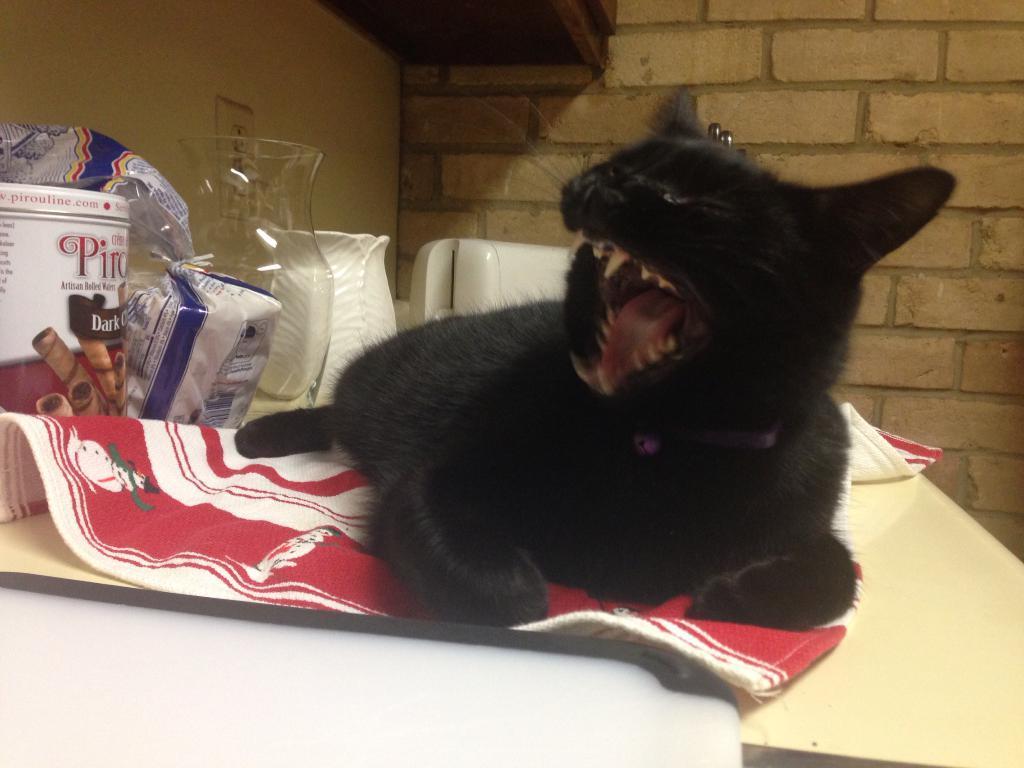Please provide a concise description of this image. Here there is cat, jar, cover, box, towel is present on the table. This is wall. 